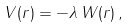<formula> <loc_0><loc_0><loc_500><loc_500>V ( { r } ) = - \lambda \, W ( { r } ) \, ,</formula> 